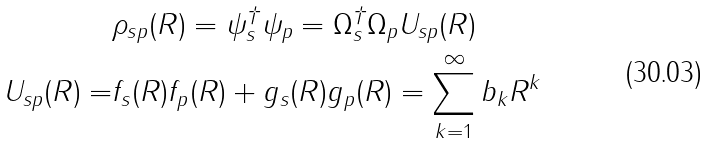<formula> <loc_0><loc_0><loc_500><loc_500>& \rho _ { s p } ( { R } ) = \psi _ { s } ^ { \dagger } \psi _ { p } = \Omega _ { s } ^ { \dagger } \Omega _ { p } U _ { s p } ( R ) \\ U _ { s p } ( R ) = & f _ { s } ( R ) f _ { p } ( R ) + g _ { s } ( R ) g _ { p } ( R ) = \sum _ { k = 1 } ^ { \infty } b _ { k } R ^ { k }</formula> 